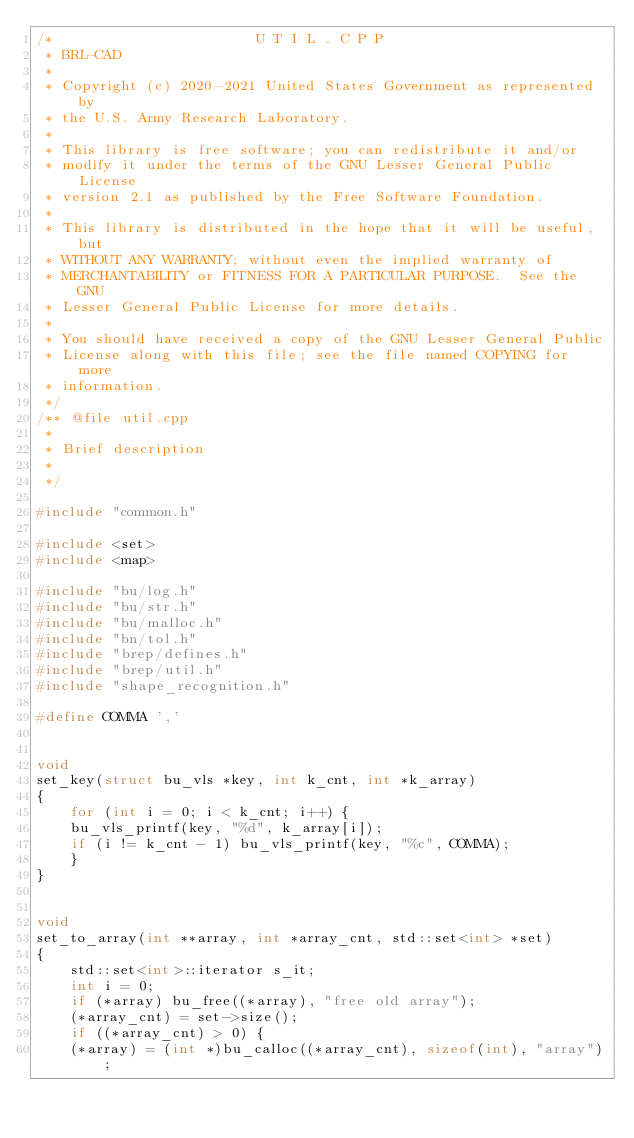<code> <loc_0><loc_0><loc_500><loc_500><_C++_>/*                        U T I L . C P P
 * BRL-CAD
 *
 * Copyright (c) 2020-2021 United States Government as represented by
 * the U.S. Army Research Laboratory.
 *
 * This library is free software; you can redistribute it and/or
 * modify it under the terms of the GNU Lesser General Public License
 * version 2.1 as published by the Free Software Foundation.
 *
 * This library is distributed in the hope that it will be useful, but
 * WITHOUT ANY WARRANTY; without even the implied warranty of
 * MERCHANTABILITY or FITNESS FOR A PARTICULAR PURPOSE.  See the GNU
 * Lesser General Public License for more details.
 *
 * You should have received a copy of the GNU Lesser General Public
 * License along with this file; see the file named COPYING for more
 * information.
 */
/** @file util.cpp
 *
 * Brief description
 *
 */

#include "common.h"

#include <set>
#include <map>

#include "bu/log.h"
#include "bu/str.h"
#include "bu/malloc.h"
#include "bn/tol.h"
#include "brep/defines.h"
#include "brep/util.h"
#include "shape_recognition.h"

#define COMMA ','


void
set_key(struct bu_vls *key, int k_cnt, int *k_array)
{
    for (int i = 0; i < k_cnt; i++) {
	bu_vls_printf(key, "%d", k_array[i]);
	if (i != k_cnt - 1) bu_vls_printf(key, "%c", COMMA);
    }
}


void
set_to_array(int **array, int *array_cnt, std::set<int> *set)
{
    std::set<int>::iterator s_it;
    int i = 0;
    if (*array) bu_free((*array), "free old array");
    (*array_cnt) = set->size();
    if ((*array_cnt) > 0) {
	(*array) = (int *)bu_calloc((*array_cnt), sizeof(int), "array");</code> 